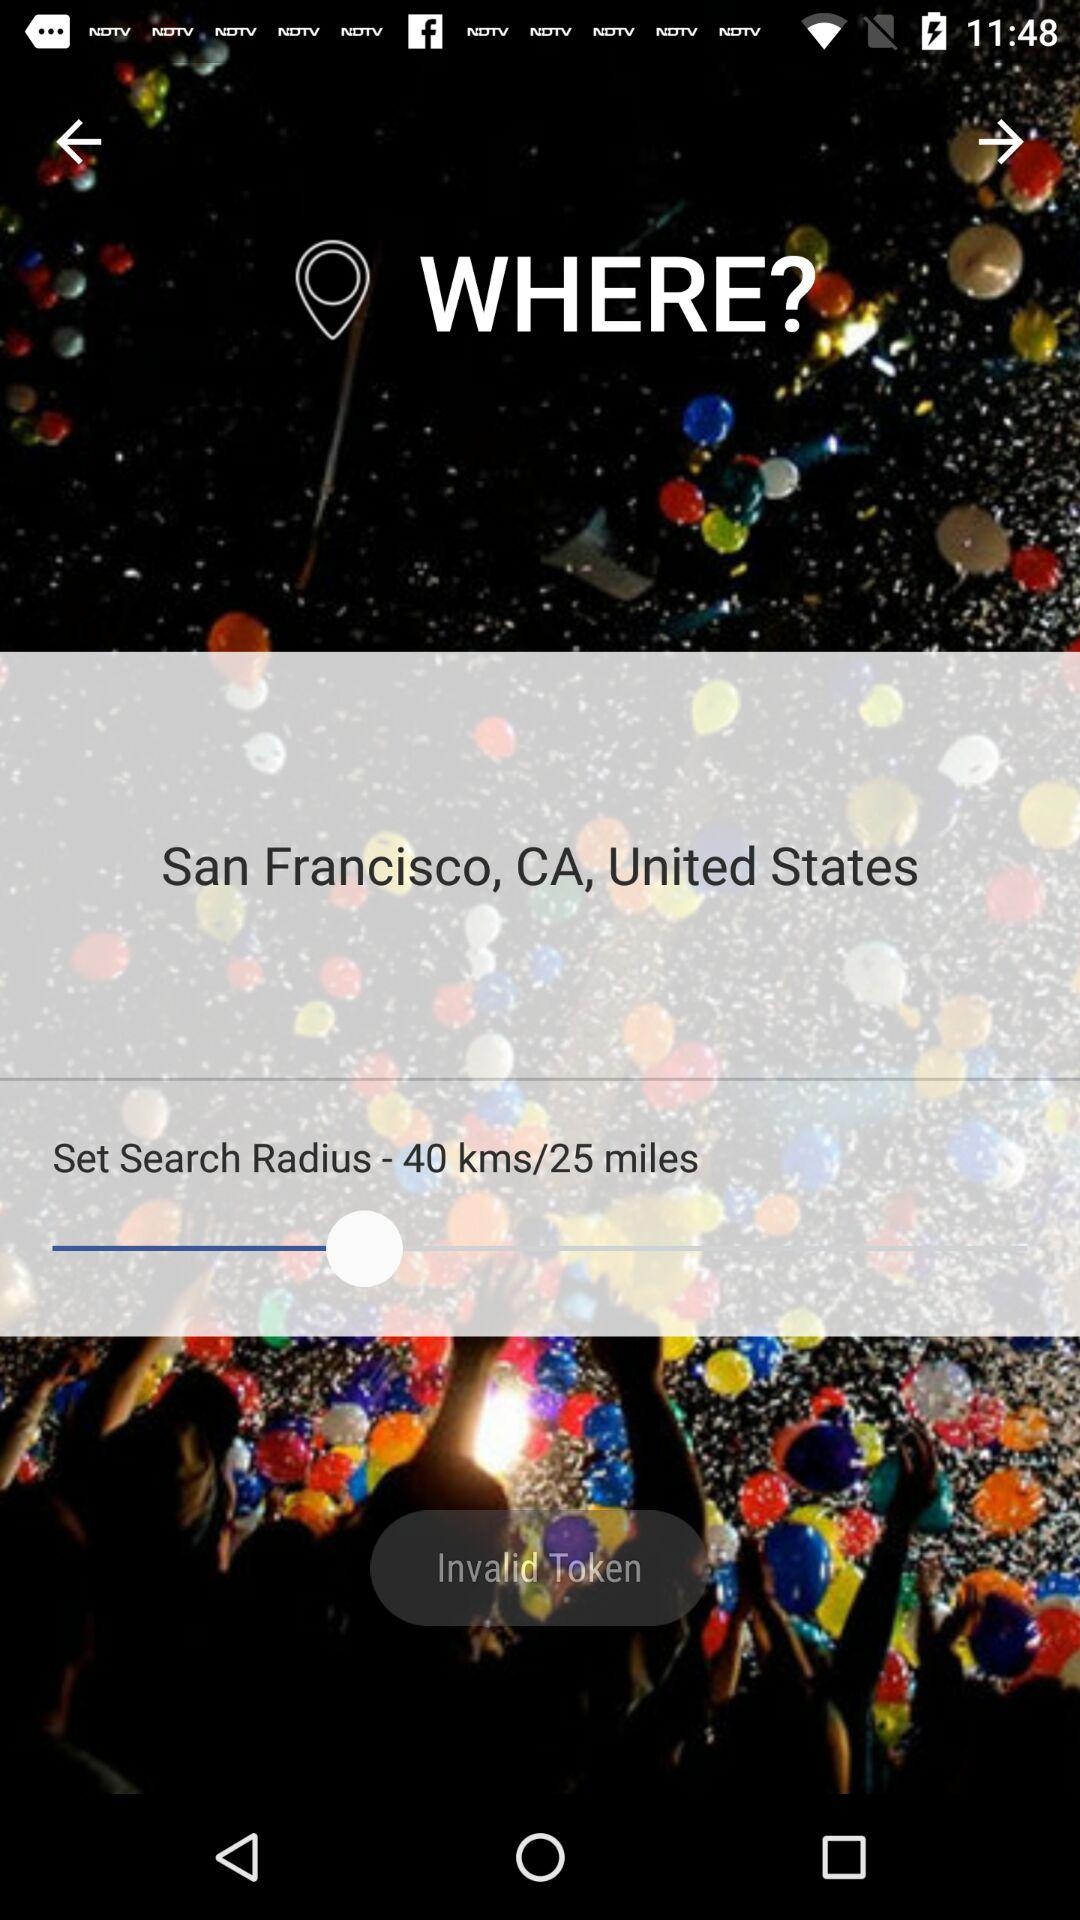What is the mentioned location? The mentioned location is San Francisco, CA, United States. 